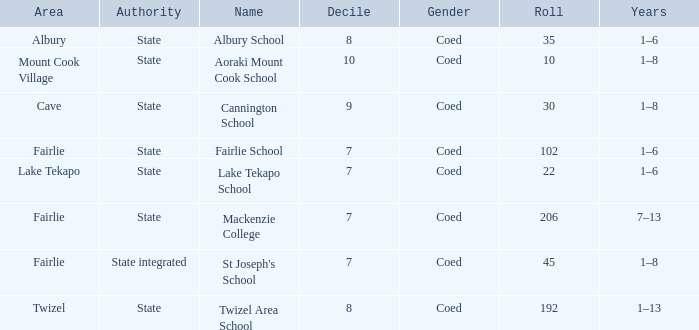What is the total Decile that has a state authority, fairlie area and roll smarter than 206? 1.0. 